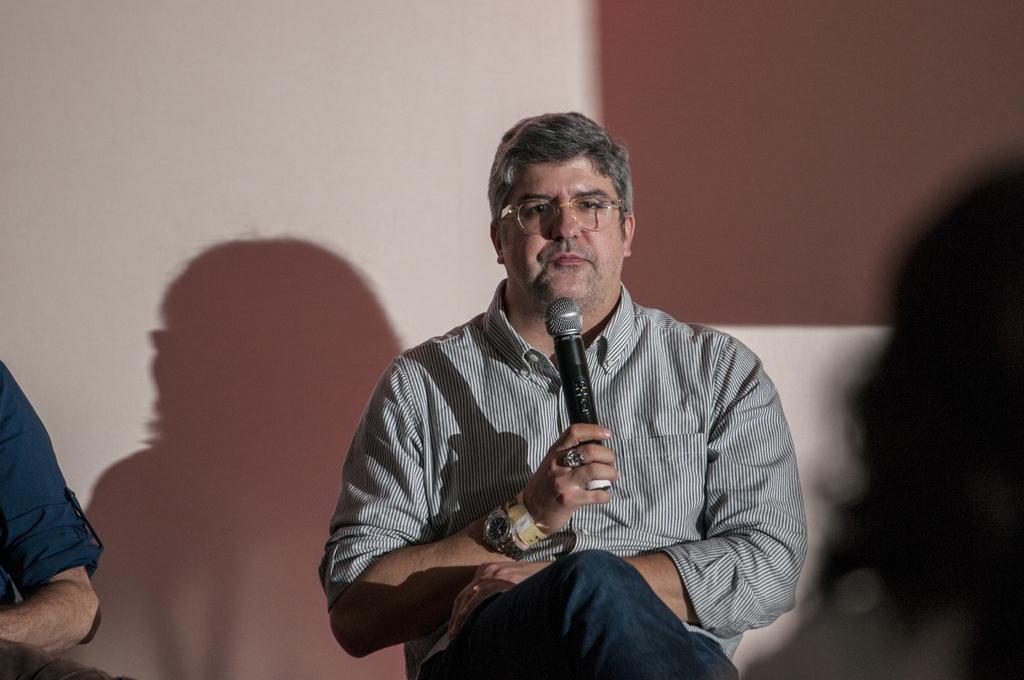How would you summarize this image in a sentence or two? In this image there is a person sitting in chair and holding a microphone and the back ground there is another person. 